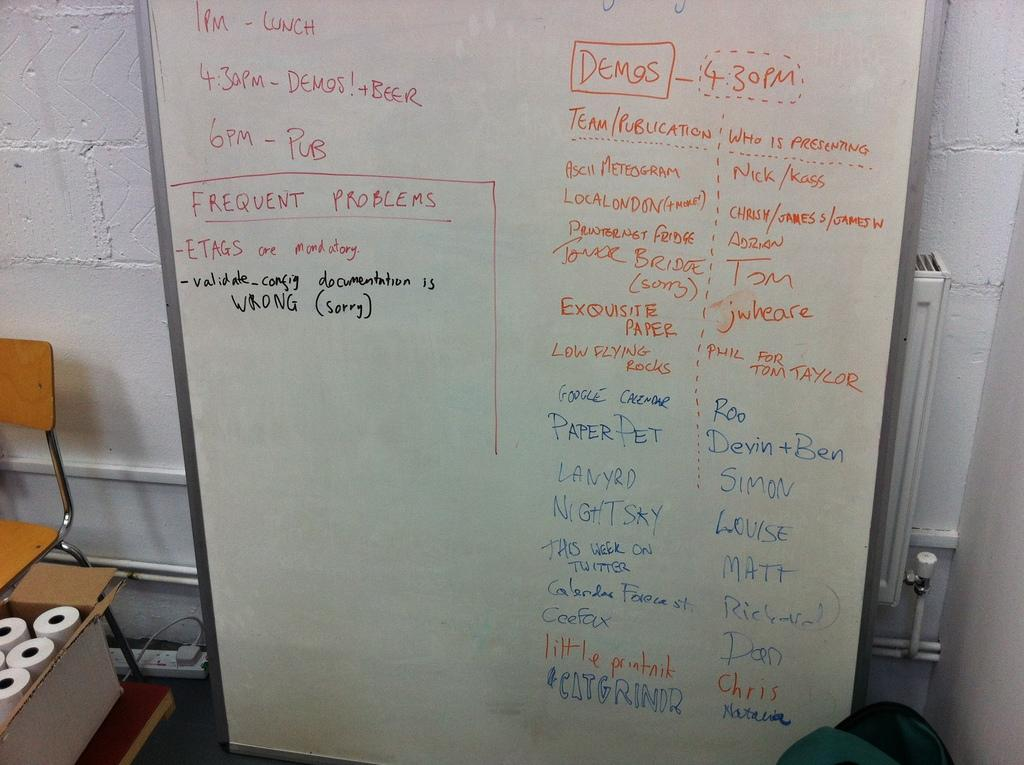<image>
Relay a brief, clear account of the picture shown. A white dry erase board with a 1 PM lunch scheduled 